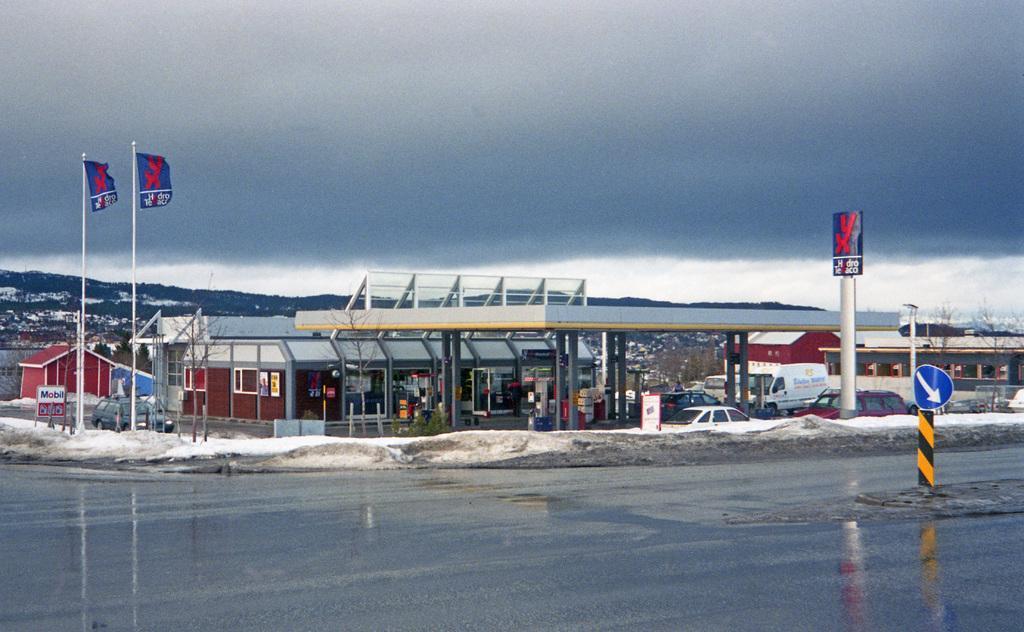Please provide a concise description of this image. In the image there is glacier in the front and behind there is a building with vehicles,flags in front of it and above its sky with clouds. 